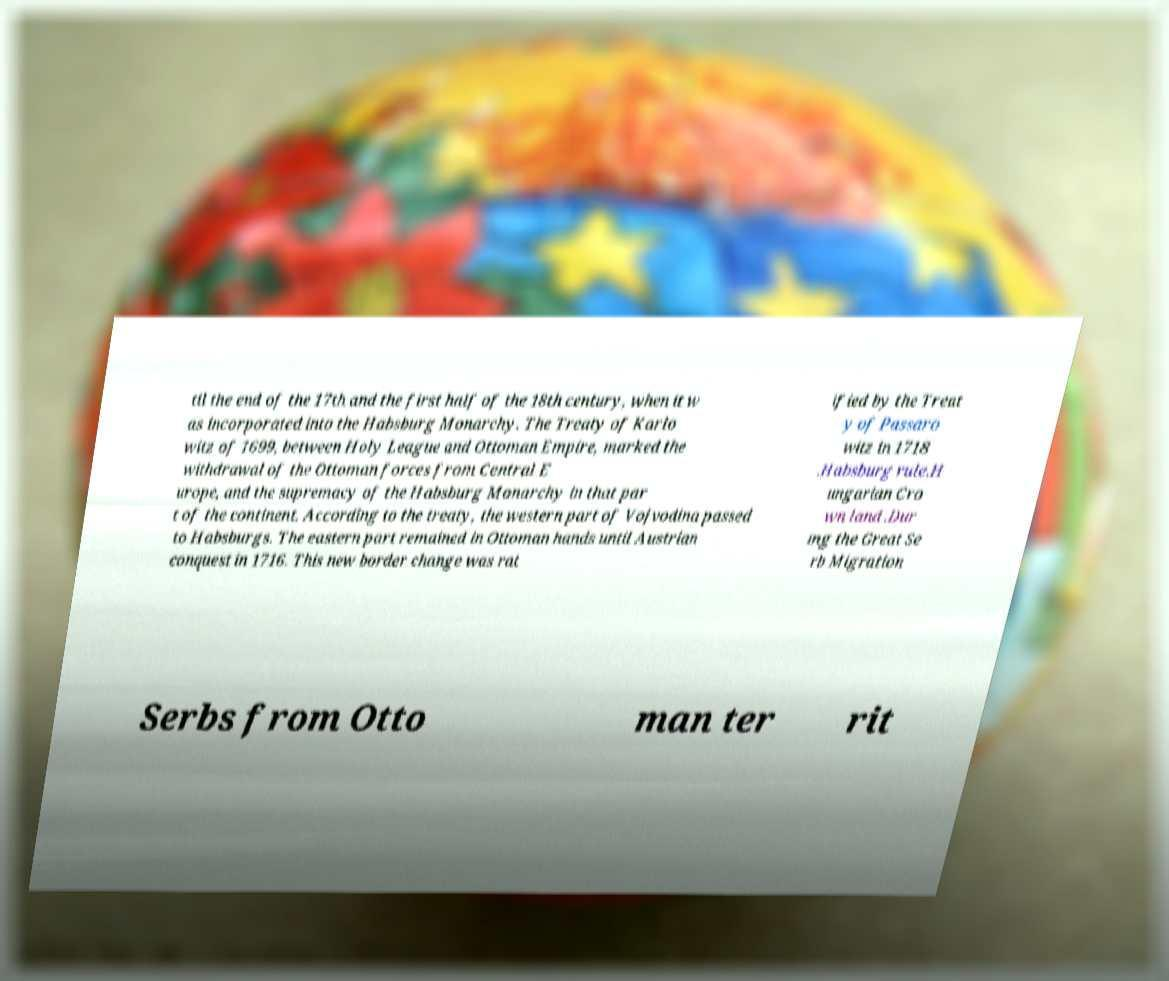Could you assist in decoding the text presented in this image and type it out clearly? til the end of the 17th and the first half of the 18th century, when it w as incorporated into the Habsburg Monarchy. The Treaty of Karlo witz of 1699, between Holy League and Ottoman Empire, marked the withdrawal of the Ottoman forces from Central E urope, and the supremacy of the Habsburg Monarchy in that par t of the continent. According to the treaty, the western part of Vojvodina passed to Habsburgs. The eastern part remained in Ottoman hands until Austrian conquest in 1716. This new border change was rat ified by the Treat y of Passaro witz in 1718 .Habsburg rule.H ungarian Cro wn land .Dur ing the Great Se rb Migration Serbs from Otto man ter rit 